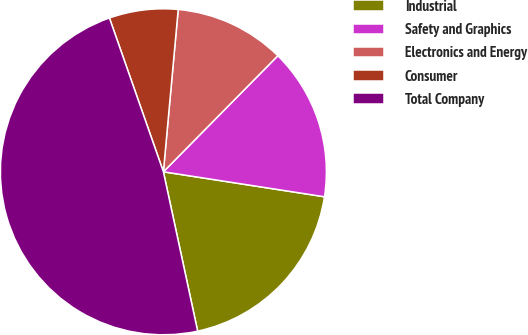Convert chart. <chart><loc_0><loc_0><loc_500><loc_500><pie_chart><fcel>Industrial<fcel>Safety and Graphics<fcel>Electronics and Energy<fcel>Consumer<fcel>Total Company<nl><fcel>19.18%<fcel>15.06%<fcel>10.94%<fcel>6.82%<fcel>48.0%<nl></chart> 